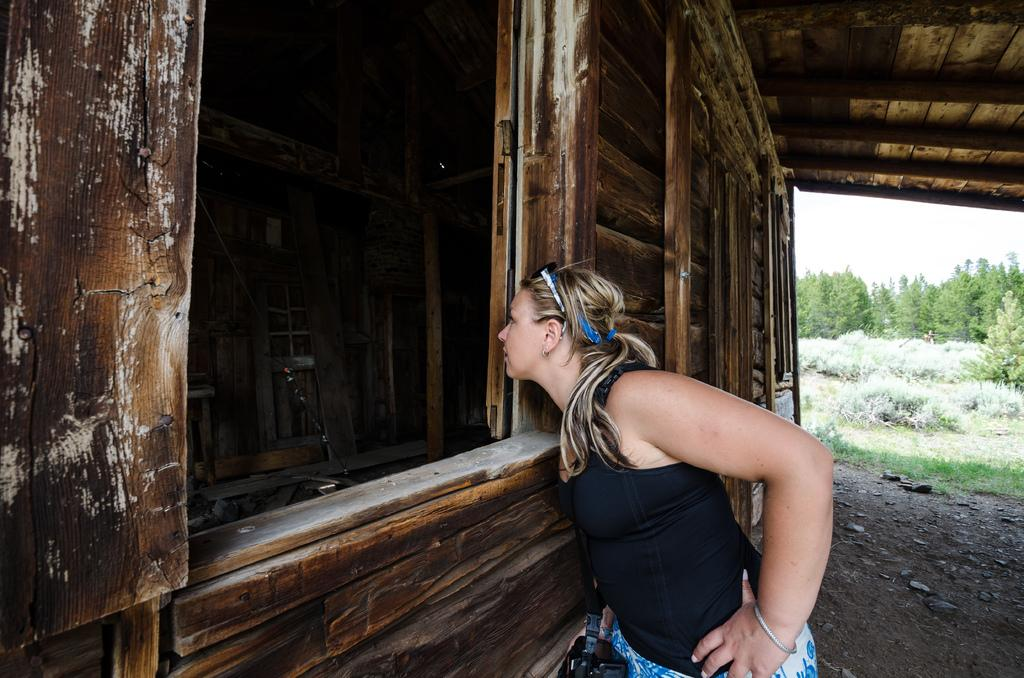Who is the main subject in the image? There is a woman in the middle of the image. What is located in front of the woman? There is a house in front of the woman. What can be seen in the background of the image? There are trees and the sky visible in the background of the image. What type of tail can be seen on the rabbit in the image? There is no rabbit present in the image, so there is no tail to observe. 